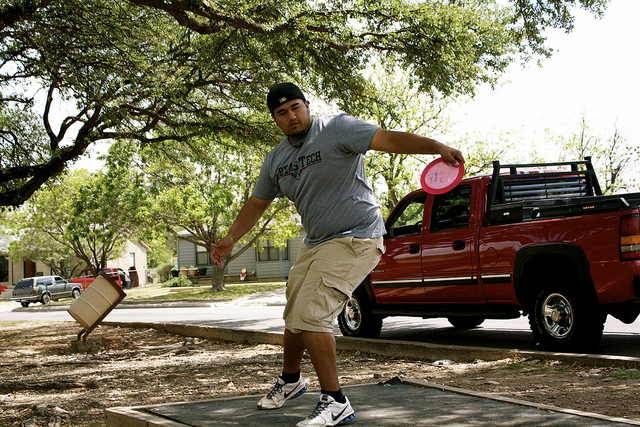Identify the text contained in this image. TECH 